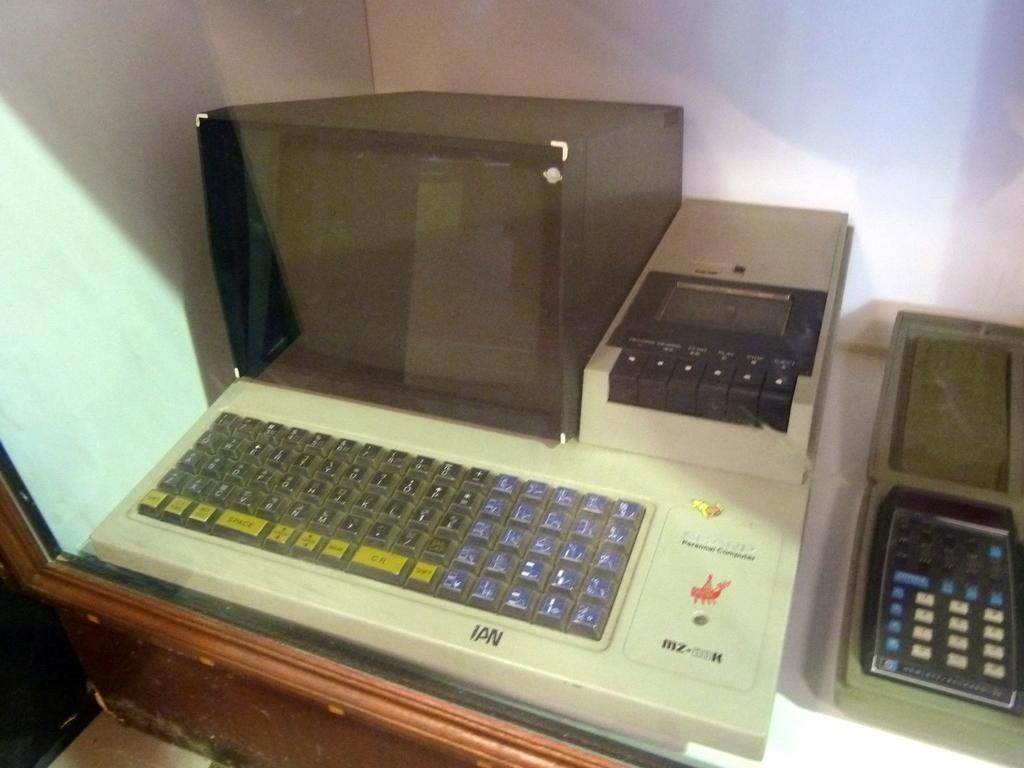<image>
Write a terse but informative summary of the picture. An older personal computer with IPN written on the bottom of it. 